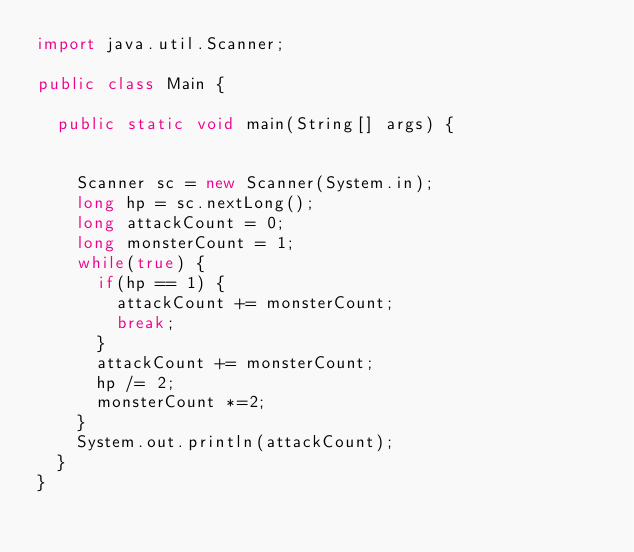Convert code to text. <code><loc_0><loc_0><loc_500><loc_500><_Java_>import java.util.Scanner;

public class Main {

	public static void main(String[] args) {


		Scanner sc = new Scanner(System.in);
		long hp = sc.nextLong();
		long attackCount = 0;
		long monsterCount = 1;
		while(true) {
			if(hp == 1) {
				attackCount += monsterCount;
				break;
			}
			attackCount += monsterCount;
			hp /= 2;
			monsterCount *=2;
		}
		System.out.println(attackCount);
	}
}</code> 